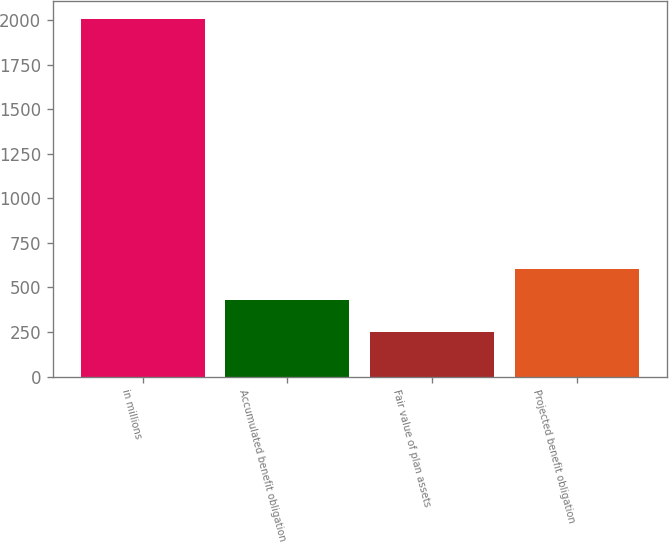<chart> <loc_0><loc_0><loc_500><loc_500><bar_chart><fcel>in millions<fcel>Accumulated benefit obligation<fcel>Fair value of plan assets<fcel>Projected benefit obligation<nl><fcel>2009<fcel>426.98<fcel>251.2<fcel>602.76<nl></chart> 